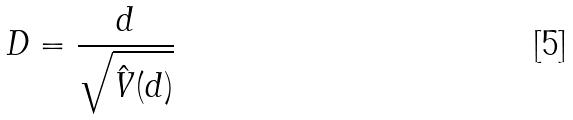Convert formula to latex. <formula><loc_0><loc_0><loc_500><loc_500>D = \frac { d } { \sqrt { \hat { V } ( d ) } }</formula> 